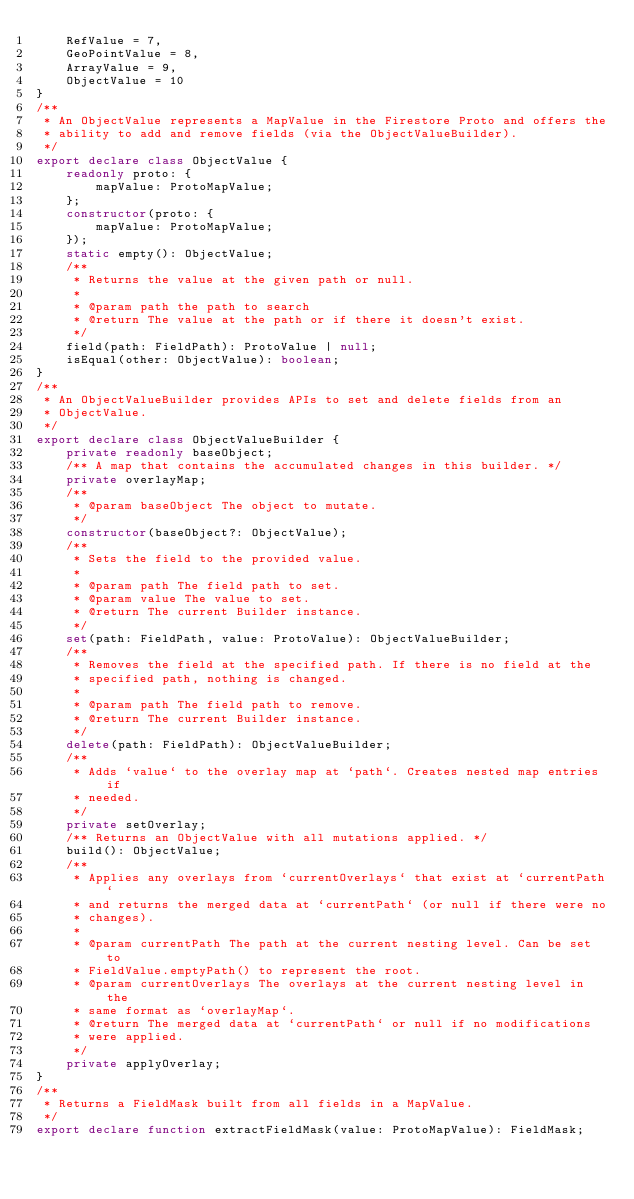Convert code to text. <code><loc_0><loc_0><loc_500><loc_500><_TypeScript_>    RefValue = 7,
    GeoPointValue = 8,
    ArrayValue = 9,
    ObjectValue = 10
}
/**
 * An ObjectValue represents a MapValue in the Firestore Proto and offers the
 * ability to add and remove fields (via the ObjectValueBuilder).
 */
export declare class ObjectValue {
    readonly proto: {
        mapValue: ProtoMapValue;
    };
    constructor(proto: {
        mapValue: ProtoMapValue;
    });
    static empty(): ObjectValue;
    /**
     * Returns the value at the given path or null.
     *
     * @param path the path to search
     * @return The value at the path or if there it doesn't exist.
     */
    field(path: FieldPath): ProtoValue | null;
    isEqual(other: ObjectValue): boolean;
}
/**
 * An ObjectValueBuilder provides APIs to set and delete fields from an
 * ObjectValue.
 */
export declare class ObjectValueBuilder {
    private readonly baseObject;
    /** A map that contains the accumulated changes in this builder. */
    private overlayMap;
    /**
     * @param baseObject The object to mutate.
     */
    constructor(baseObject?: ObjectValue);
    /**
     * Sets the field to the provided value.
     *
     * @param path The field path to set.
     * @param value The value to set.
     * @return The current Builder instance.
     */
    set(path: FieldPath, value: ProtoValue): ObjectValueBuilder;
    /**
     * Removes the field at the specified path. If there is no field at the
     * specified path, nothing is changed.
     *
     * @param path The field path to remove.
     * @return The current Builder instance.
     */
    delete(path: FieldPath): ObjectValueBuilder;
    /**
     * Adds `value` to the overlay map at `path`. Creates nested map entries if
     * needed.
     */
    private setOverlay;
    /** Returns an ObjectValue with all mutations applied. */
    build(): ObjectValue;
    /**
     * Applies any overlays from `currentOverlays` that exist at `currentPath`
     * and returns the merged data at `currentPath` (or null if there were no
     * changes).
     *
     * @param currentPath The path at the current nesting level. Can be set to
     * FieldValue.emptyPath() to represent the root.
     * @param currentOverlays The overlays at the current nesting level in the
     * same format as `overlayMap`.
     * @return The merged data at `currentPath` or null if no modifications
     * were applied.
     */
    private applyOverlay;
}
/**
 * Returns a FieldMask built from all fields in a MapValue.
 */
export declare function extractFieldMask(value: ProtoMapValue): FieldMask;
</code> 